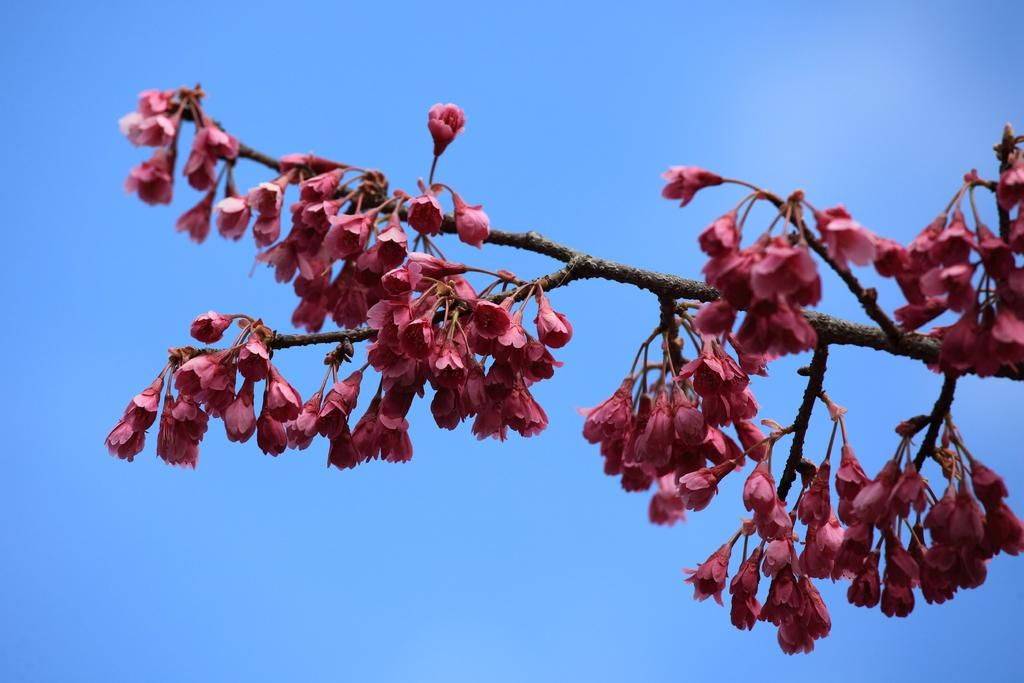What type of plant life is present in the image? There are flowers and branches of a tree in the image. What can be seen in the background of the image? The sky is visible in the image. What type of holiday is being celebrated in the image? There is no indication of a holiday being celebrated in the image. What type of beetle can be seen crawling on the flowers in the image? There are no beetles present in the image; only flowers and tree branches are visible. 